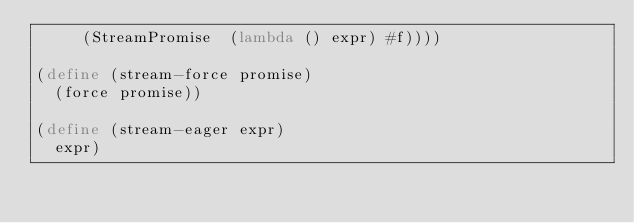<code> <loc_0><loc_0><loc_500><loc_500><_Scheme_>     (StreamPromise  (lambda () expr) #f))))

(define (stream-force promise)
  (force promise))

(define (stream-eager expr)
  expr)
</code> 